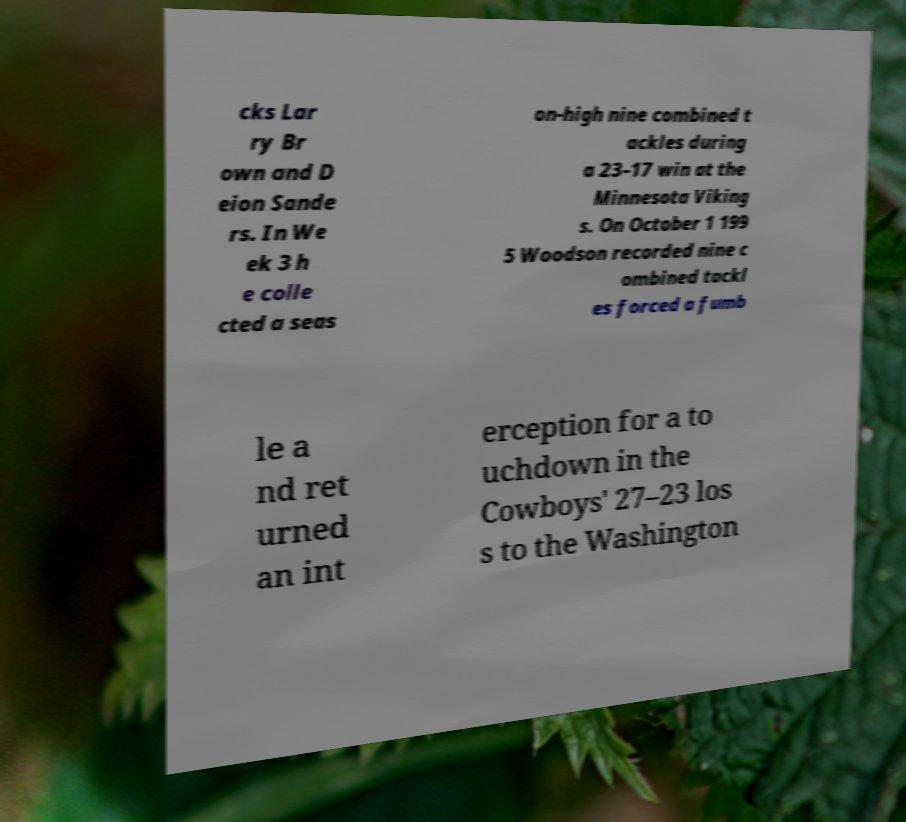There's text embedded in this image that I need extracted. Can you transcribe it verbatim? cks Lar ry Br own and D eion Sande rs. In We ek 3 h e colle cted a seas on-high nine combined t ackles during a 23–17 win at the Minnesota Viking s. On October 1 199 5 Woodson recorded nine c ombined tackl es forced a fumb le a nd ret urned an int erception for a to uchdown in the Cowboys' 27–23 los s to the Washington 